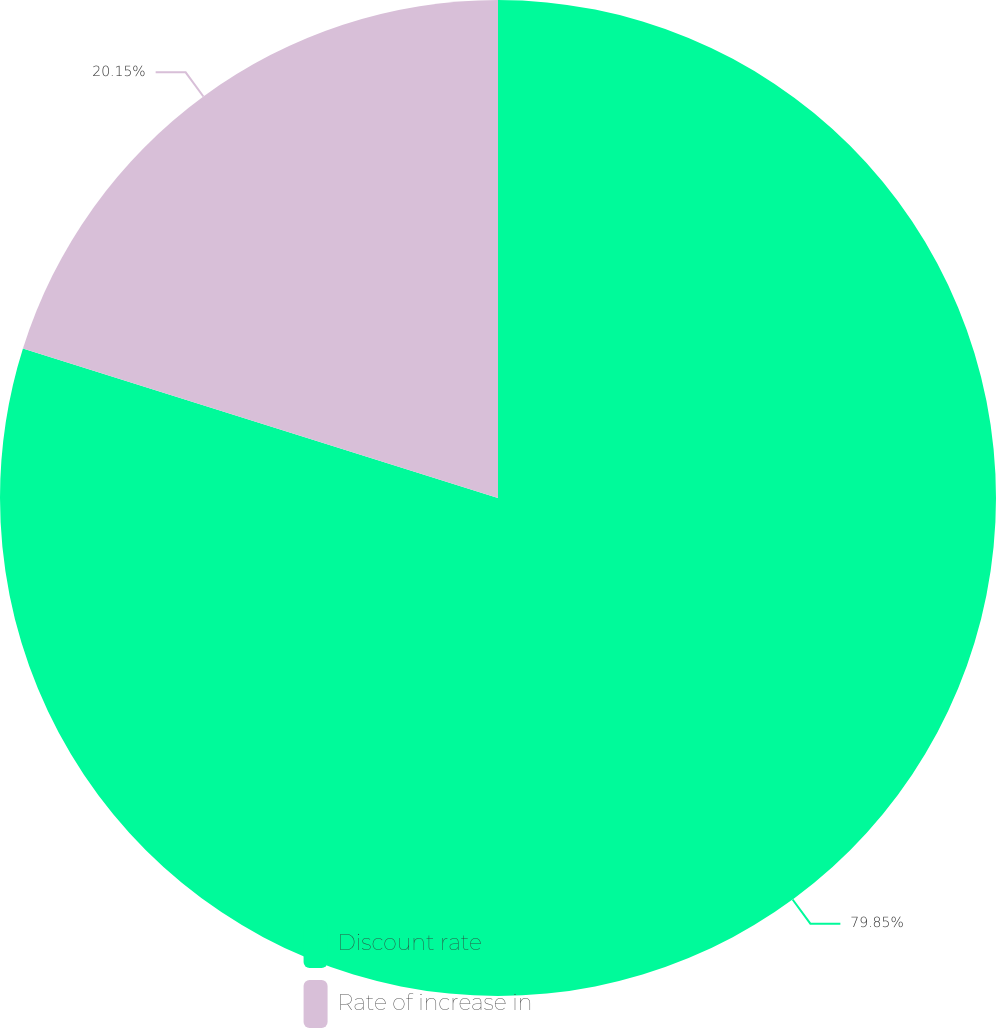Convert chart. <chart><loc_0><loc_0><loc_500><loc_500><pie_chart><fcel>Discount rate<fcel>Rate of increase in<nl><fcel>79.85%<fcel>20.15%<nl></chart> 